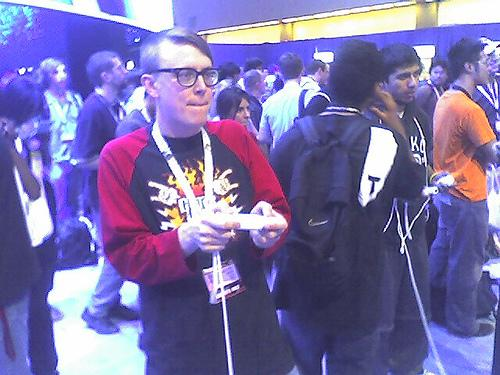What is the man in the black glasses using the white remote to do? Please explain your reasoning. play games. The remote is for a wii system. 